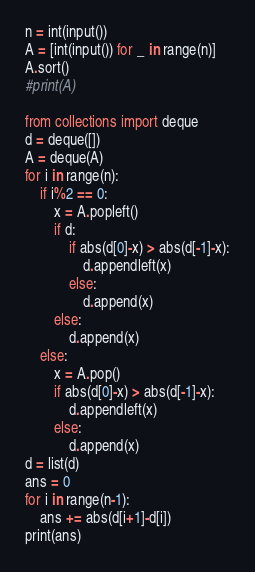Convert code to text. <code><loc_0><loc_0><loc_500><loc_500><_Python_>n = int(input())
A = [int(input()) for _ in range(n)]
A.sort()
#print(A)

from collections import deque
d = deque([])
A = deque(A)
for i in range(n):
    if i%2 == 0:
        x = A.popleft()
        if d:
            if abs(d[0]-x) > abs(d[-1]-x):
                d.appendleft(x)
            else:
                d.append(x)
        else:
            d.append(x)
    else:
        x = A.pop()
        if abs(d[0]-x) > abs(d[-1]-x):
            d.appendleft(x)
        else:
            d.append(x)
d = list(d)
ans = 0
for i in range(n-1):
    ans += abs(d[i+1]-d[i])
print(ans)
</code> 